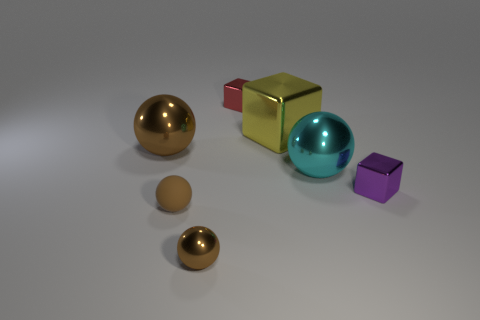How many things are large shiny things that are to the left of the small brown metal object or metal balls that are in front of the matte sphere?
Provide a short and direct response. 2. Is the number of small red cubes left of the big metal block less than the number of big metal balls?
Your response must be concise. Yes. Are there any cyan shiny things of the same size as the red thing?
Ensure brevity in your answer.  No. The tiny shiny sphere is what color?
Your response must be concise. Brown. Does the cyan ball have the same size as the yellow thing?
Provide a short and direct response. Yes. How many objects are either blue spheres or purple metal objects?
Provide a short and direct response. 1. Are there an equal number of red cubes that are on the right side of the tiny red cube and small purple cylinders?
Make the answer very short. Yes. Are there any large metallic objects that are behind the big metal thing that is behind the metallic object that is on the left side of the small shiny ball?
Your answer should be compact. No. There is a tiny sphere that is made of the same material as the large yellow thing; what color is it?
Give a very brief answer. Brown. Is the color of the tiny cube that is in front of the large yellow block the same as the tiny matte thing?
Make the answer very short. No. 